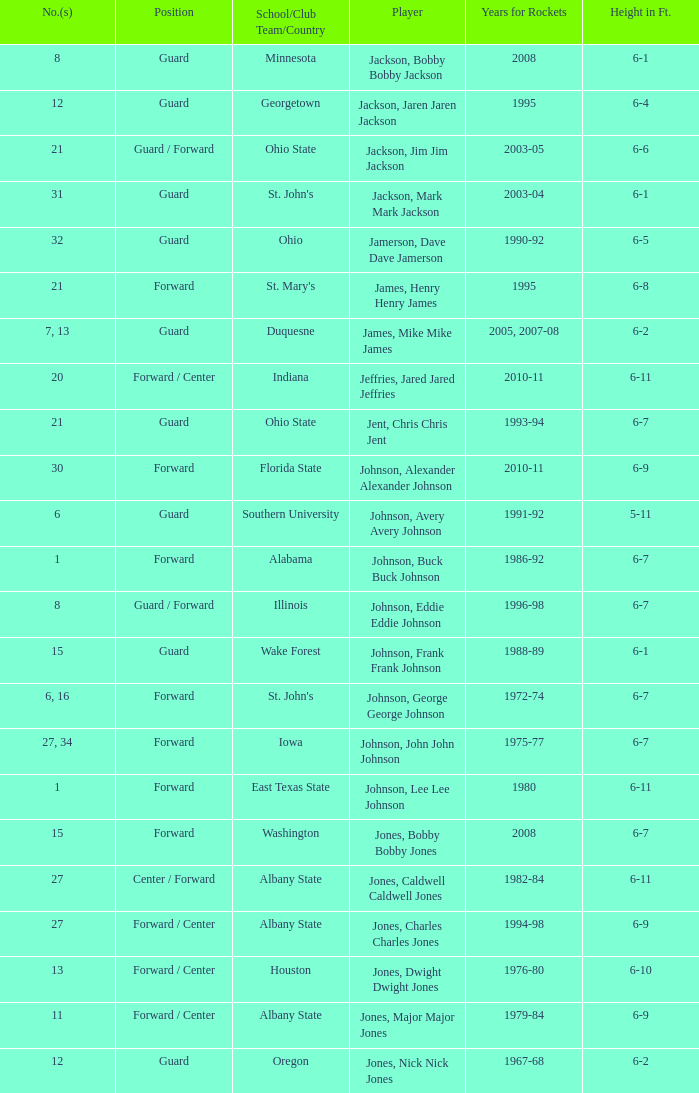Can you give me this table as a dict? {'header': ['No.(s)', 'Position', 'School/Club Team/Country', 'Player', 'Years for Rockets', 'Height in Ft.'], 'rows': [['8', 'Guard', 'Minnesota', 'Jackson, Bobby Bobby Jackson', '2008', '6-1'], ['12', 'Guard', 'Georgetown', 'Jackson, Jaren Jaren Jackson', '1995', '6-4'], ['21', 'Guard / Forward', 'Ohio State', 'Jackson, Jim Jim Jackson', '2003-05', '6-6'], ['31', 'Guard', "St. John's", 'Jackson, Mark Mark Jackson', '2003-04', '6-1'], ['32', 'Guard', 'Ohio', 'Jamerson, Dave Dave Jamerson', '1990-92', '6-5'], ['21', 'Forward', "St. Mary's", 'James, Henry Henry James', '1995', '6-8'], ['7, 13', 'Guard', 'Duquesne', 'James, Mike Mike James', '2005, 2007-08', '6-2'], ['20', 'Forward / Center', 'Indiana', 'Jeffries, Jared Jared Jeffries', '2010-11', '6-11'], ['21', 'Guard', 'Ohio State', 'Jent, Chris Chris Jent', '1993-94', '6-7'], ['30', 'Forward', 'Florida State', 'Johnson, Alexander Alexander Johnson', '2010-11', '6-9'], ['6', 'Guard', 'Southern University', 'Johnson, Avery Avery Johnson', '1991-92', '5-11'], ['1', 'Forward', 'Alabama', 'Johnson, Buck Buck Johnson', '1986-92', '6-7'], ['8', 'Guard / Forward', 'Illinois', 'Johnson, Eddie Eddie Johnson', '1996-98', '6-7'], ['15', 'Guard', 'Wake Forest', 'Johnson, Frank Frank Johnson', '1988-89', '6-1'], ['6, 16', 'Forward', "St. John's", 'Johnson, George George Johnson', '1972-74', '6-7'], ['27, 34', 'Forward', 'Iowa', 'Johnson, John John Johnson', '1975-77', '6-7'], ['1', 'Forward', 'East Texas State', 'Johnson, Lee Lee Johnson', '1980', '6-11'], ['15', 'Forward', 'Washington', 'Jones, Bobby Bobby Jones', '2008', '6-7'], ['27', 'Center / Forward', 'Albany State', 'Jones, Caldwell Caldwell Jones', '1982-84', '6-11'], ['27', 'Forward / Center', 'Albany State', 'Jones, Charles Charles Jones', '1994-98', '6-9'], ['13', 'Forward / Center', 'Houston', 'Jones, Dwight Dwight Jones', '1976-80', '6-10'], ['11', 'Forward / Center', 'Albany State', 'Jones, Major Major Jones', '1979-84', '6-9'], ['12', 'Guard', 'Oregon', 'Jones, Nick Nick Jones', '1967-68', '6-2']]} What is the number of the player who went to Southern University? 6.0. 